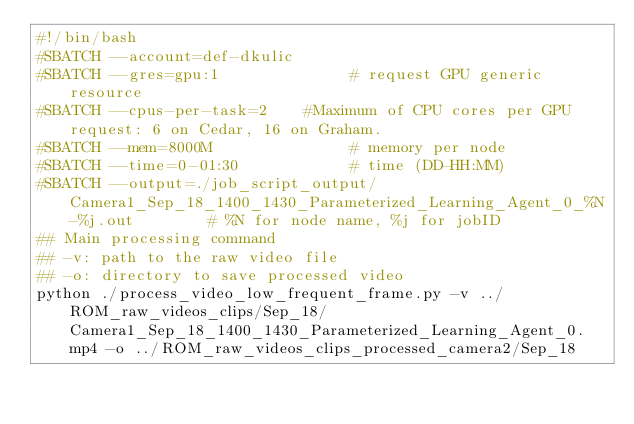Convert code to text. <code><loc_0><loc_0><loc_500><loc_500><_Bash_>#!/bin/bash
#SBATCH --account=def-dkulic
#SBATCH --gres=gpu:1              # request GPU generic resource
#SBATCH --cpus-per-task=2    #Maximum of CPU cores per GPU request: 6 on Cedar, 16 on Graham.
#SBATCH --mem=8000M               # memory per node
#SBATCH --time=0-01:30            # time (DD-HH:MM)
#SBATCH --output=./job_script_output/Camera1_Sep_18_1400_1430_Parameterized_Learning_Agent_0_%N-%j.out        # %N for node name, %j for jobID
## Main processing command
## -v: path to the raw video file
## -o: directory to save processed video
python ./process_video_low_frequent_frame.py -v ../ROM_raw_videos_clips/Sep_18/Camera1_Sep_18_1400_1430_Parameterized_Learning_Agent_0.mp4 -o ../ROM_raw_videos_clips_processed_camera2/Sep_18
</code> 